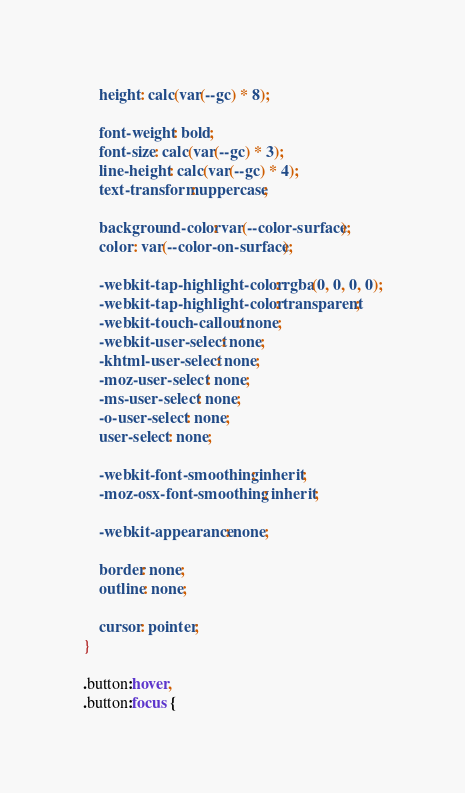<code> <loc_0><loc_0><loc_500><loc_500><_CSS_>    height: calc(var(--gc) * 8);

    font-weight: bold;
    font-size: calc(var(--gc) * 3);
    line-height: calc(var(--gc) * 4);
    text-transform: uppercase;

    background-color: var(--color-surface);
    color: var(--color-on-surface);

    -webkit-tap-highlight-color: rgba(0, 0, 0, 0);
    -webkit-tap-highlight-color: transparent;
    -webkit-touch-callout: none;
    -webkit-user-select: none;
    -khtml-user-select: none;
    -moz-user-select: none;
    -ms-user-select: none;
    -o-user-select: none;
    user-select: none;

    -webkit-font-smoothing: inherit;
    -moz-osx-font-smoothing: inherit;

    -webkit-appearance: none;

    border: none;
    outline: none;

    cursor: pointer;
}

.button:hover,
.button:focus {</code> 